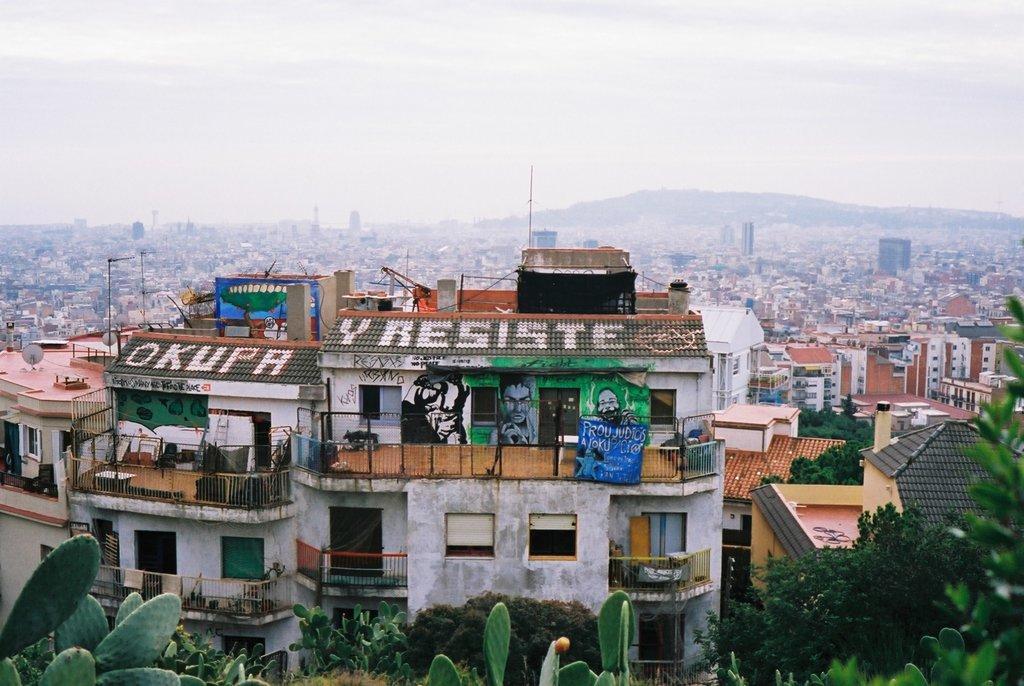In one or two sentences, can you explain what this image depicts? In this image, I can see the view of a city with the buildings and trees. In the background, there is a hill and the sky. 